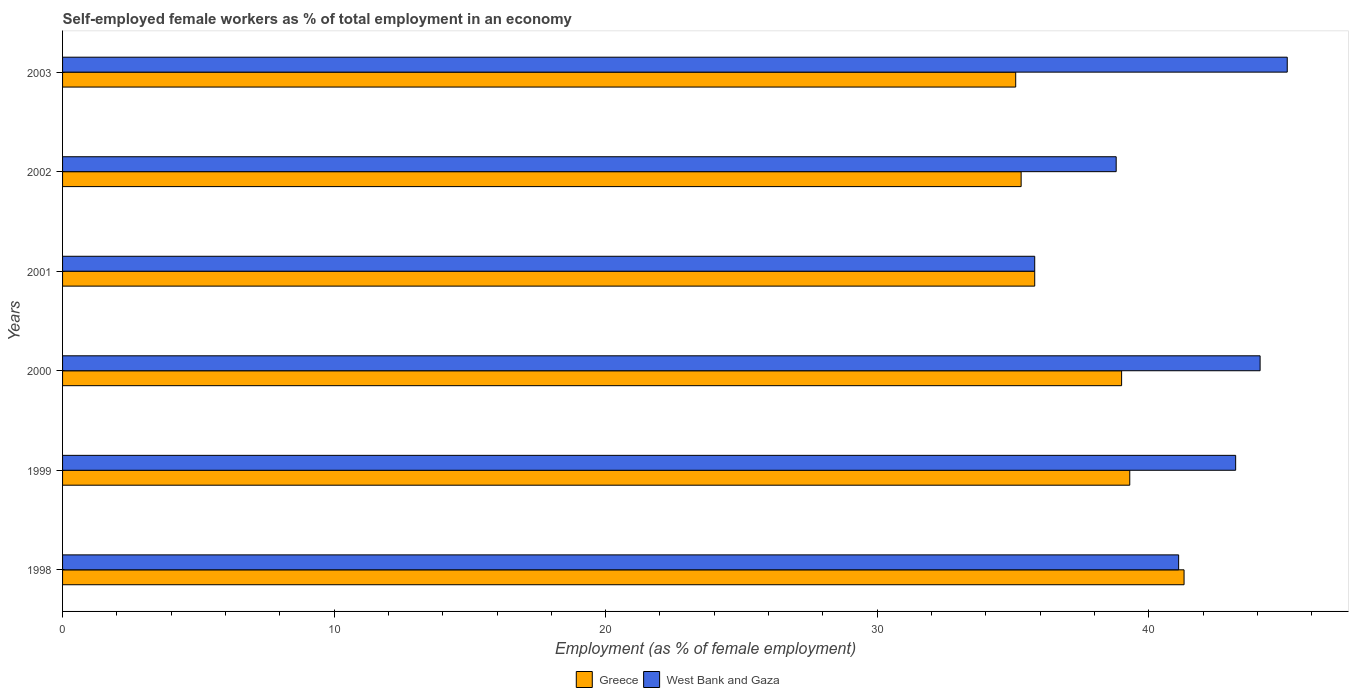How many groups of bars are there?
Offer a terse response. 6. Are the number of bars per tick equal to the number of legend labels?
Your response must be concise. Yes. Are the number of bars on each tick of the Y-axis equal?
Give a very brief answer. Yes. What is the label of the 1st group of bars from the top?
Provide a short and direct response. 2003. What is the percentage of self-employed female workers in Greece in 1999?
Provide a short and direct response. 39.3. Across all years, what is the maximum percentage of self-employed female workers in Greece?
Make the answer very short. 41.3. Across all years, what is the minimum percentage of self-employed female workers in West Bank and Gaza?
Keep it short and to the point. 35.8. In which year was the percentage of self-employed female workers in Greece maximum?
Your answer should be compact. 1998. What is the total percentage of self-employed female workers in Greece in the graph?
Keep it short and to the point. 225.8. What is the difference between the percentage of self-employed female workers in Greece in 1998 and the percentage of self-employed female workers in West Bank and Gaza in 2003?
Provide a succinct answer. -3.8. What is the average percentage of self-employed female workers in West Bank and Gaza per year?
Offer a very short reply. 41.35. What is the ratio of the percentage of self-employed female workers in West Bank and Gaza in 1999 to that in 2000?
Ensure brevity in your answer.  0.98. Is the difference between the percentage of self-employed female workers in West Bank and Gaza in 1999 and 2003 greater than the difference between the percentage of self-employed female workers in Greece in 1999 and 2003?
Your response must be concise. No. What is the difference between the highest and the second highest percentage of self-employed female workers in Greece?
Provide a succinct answer. 2. What is the difference between the highest and the lowest percentage of self-employed female workers in Greece?
Your response must be concise. 6.2. In how many years, is the percentage of self-employed female workers in Greece greater than the average percentage of self-employed female workers in Greece taken over all years?
Your response must be concise. 3. How many bars are there?
Your answer should be very brief. 12. Does the graph contain any zero values?
Provide a succinct answer. No. Does the graph contain grids?
Provide a succinct answer. No. How are the legend labels stacked?
Make the answer very short. Horizontal. What is the title of the graph?
Provide a succinct answer. Self-employed female workers as % of total employment in an economy. What is the label or title of the X-axis?
Offer a terse response. Employment (as % of female employment). What is the label or title of the Y-axis?
Ensure brevity in your answer.  Years. What is the Employment (as % of female employment) in Greece in 1998?
Provide a short and direct response. 41.3. What is the Employment (as % of female employment) in West Bank and Gaza in 1998?
Your answer should be very brief. 41.1. What is the Employment (as % of female employment) of Greece in 1999?
Your response must be concise. 39.3. What is the Employment (as % of female employment) of West Bank and Gaza in 1999?
Your answer should be compact. 43.2. What is the Employment (as % of female employment) in West Bank and Gaza in 2000?
Offer a very short reply. 44.1. What is the Employment (as % of female employment) of Greece in 2001?
Provide a short and direct response. 35.8. What is the Employment (as % of female employment) of West Bank and Gaza in 2001?
Ensure brevity in your answer.  35.8. What is the Employment (as % of female employment) in Greece in 2002?
Your answer should be compact. 35.3. What is the Employment (as % of female employment) of West Bank and Gaza in 2002?
Offer a very short reply. 38.8. What is the Employment (as % of female employment) in Greece in 2003?
Keep it short and to the point. 35.1. What is the Employment (as % of female employment) in West Bank and Gaza in 2003?
Provide a succinct answer. 45.1. Across all years, what is the maximum Employment (as % of female employment) of Greece?
Your answer should be very brief. 41.3. Across all years, what is the maximum Employment (as % of female employment) of West Bank and Gaza?
Your answer should be compact. 45.1. Across all years, what is the minimum Employment (as % of female employment) of Greece?
Keep it short and to the point. 35.1. Across all years, what is the minimum Employment (as % of female employment) of West Bank and Gaza?
Give a very brief answer. 35.8. What is the total Employment (as % of female employment) in Greece in the graph?
Provide a succinct answer. 225.8. What is the total Employment (as % of female employment) in West Bank and Gaza in the graph?
Your answer should be compact. 248.1. What is the difference between the Employment (as % of female employment) in West Bank and Gaza in 1998 and that in 1999?
Offer a terse response. -2.1. What is the difference between the Employment (as % of female employment) of Greece in 1998 and that in 2000?
Provide a succinct answer. 2.3. What is the difference between the Employment (as % of female employment) in West Bank and Gaza in 1998 and that in 2000?
Your response must be concise. -3. What is the difference between the Employment (as % of female employment) in West Bank and Gaza in 1998 and that in 2002?
Make the answer very short. 2.3. What is the difference between the Employment (as % of female employment) of Greece in 1998 and that in 2003?
Make the answer very short. 6.2. What is the difference between the Employment (as % of female employment) of West Bank and Gaza in 1998 and that in 2003?
Your response must be concise. -4. What is the difference between the Employment (as % of female employment) in Greece in 1999 and that in 2001?
Offer a very short reply. 3.5. What is the difference between the Employment (as % of female employment) in West Bank and Gaza in 1999 and that in 2001?
Provide a short and direct response. 7.4. What is the difference between the Employment (as % of female employment) of Greece in 1999 and that in 2002?
Ensure brevity in your answer.  4. What is the difference between the Employment (as % of female employment) in West Bank and Gaza in 1999 and that in 2002?
Give a very brief answer. 4.4. What is the difference between the Employment (as % of female employment) of Greece in 2000 and that in 2002?
Your answer should be very brief. 3.7. What is the difference between the Employment (as % of female employment) in Greece in 2000 and that in 2003?
Offer a terse response. 3.9. What is the difference between the Employment (as % of female employment) in Greece in 2001 and that in 2002?
Provide a succinct answer. 0.5. What is the difference between the Employment (as % of female employment) in West Bank and Gaza in 2001 and that in 2002?
Offer a terse response. -3. What is the difference between the Employment (as % of female employment) of Greece in 2001 and that in 2003?
Give a very brief answer. 0.7. What is the difference between the Employment (as % of female employment) in Greece in 2002 and that in 2003?
Your answer should be compact. 0.2. What is the difference between the Employment (as % of female employment) of Greece in 1998 and the Employment (as % of female employment) of West Bank and Gaza in 1999?
Offer a terse response. -1.9. What is the difference between the Employment (as % of female employment) in Greece in 1998 and the Employment (as % of female employment) in West Bank and Gaza in 2001?
Your answer should be compact. 5.5. What is the difference between the Employment (as % of female employment) in Greece in 1998 and the Employment (as % of female employment) in West Bank and Gaza in 2003?
Your answer should be very brief. -3.8. What is the difference between the Employment (as % of female employment) in Greece in 1999 and the Employment (as % of female employment) in West Bank and Gaza in 2001?
Your answer should be very brief. 3.5. What is the difference between the Employment (as % of female employment) of Greece in 2000 and the Employment (as % of female employment) of West Bank and Gaza in 2001?
Keep it short and to the point. 3.2. What is the difference between the Employment (as % of female employment) in Greece in 2002 and the Employment (as % of female employment) in West Bank and Gaza in 2003?
Offer a very short reply. -9.8. What is the average Employment (as % of female employment) in Greece per year?
Your answer should be very brief. 37.63. What is the average Employment (as % of female employment) in West Bank and Gaza per year?
Your response must be concise. 41.35. In the year 1999, what is the difference between the Employment (as % of female employment) in Greece and Employment (as % of female employment) in West Bank and Gaza?
Your answer should be compact. -3.9. In the year 2000, what is the difference between the Employment (as % of female employment) in Greece and Employment (as % of female employment) in West Bank and Gaza?
Your answer should be very brief. -5.1. In the year 2001, what is the difference between the Employment (as % of female employment) in Greece and Employment (as % of female employment) in West Bank and Gaza?
Offer a very short reply. 0. In the year 2002, what is the difference between the Employment (as % of female employment) in Greece and Employment (as % of female employment) in West Bank and Gaza?
Your response must be concise. -3.5. What is the ratio of the Employment (as % of female employment) in Greece in 1998 to that in 1999?
Your response must be concise. 1.05. What is the ratio of the Employment (as % of female employment) in West Bank and Gaza in 1998 to that in 1999?
Ensure brevity in your answer.  0.95. What is the ratio of the Employment (as % of female employment) of Greece in 1998 to that in 2000?
Your answer should be compact. 1.06. What is the ratio of the Employment (as % of female employment) in West Bank and Gaza in 1998 to that in 2000?
Offer a very short reply. 0.93. What is the ratio of the Employment (as % of female employment) of Greece in 1998 to that in 2001?
Keep it short and to the point. 1.15. What is the ratio of the Employment (as % of female employment) of West Bank and Gaza in 1998 to that in 2001?
Your answer should be compact. 1.15. What is the ratio of the Employment (as % of female employment) of Greece in 1998 to that in 2002?
Your answer should be compact. 1.17. What is the ratio of the Employment (as % of female employment) in West Bank and Gaza in 1998 to that in 2002?
Make the answer very short. 1.06. What is the ratio of the Employment (as % of female employment) of Greece in 1998 to that in 2003?
Make the answer very short. 1.18. What is the ratio of the Employment (as % of female employment) in West Bank and Gaza in 1998 to that in 2003?
Give a very brief answer. 0.91. What is the ratio of the Employment (as % of female employment) of Greece in 1999 to that in 2000?
Your answer should be compact. 1.01. What is the ratio of the Employment (as % of female employment) of West Bank and Gaza in 1999 to that in 2000?
Ensure brevity in your answer.  0.98. What is the ratio of the Employment (as % of female employment) of Greece in 1999 to that in 2001?
Offer a very short reply. 1.1. What is the ratio of the Employment (as % of female employment) in West Bank and Gaza in 1999 to that in 2001?
Give a very brief answer. 1.21. What is the ratio of the Employment (as % of female employment) of Greece in 1999 to that in 2002?
Offer a very short reply. 1.11. What is the ratio of the Employment (as % of female employment) in West Bank and Gaza in 1999 to that in 2002?
Offer a terse response. 1.11. What is the ratio of the Employment (as % of female employment) of Greece in 1999 to that in 2003?
Offer a terse response. 1.12. What is the ratio of the Employment (as % of female employment) in West Bank and Gaza in 1999 to that in 2003?
Make the answer very short. 0.96. What is the ratio of the Employment (as % of female employment) of Greece in 2000 to that in 2001?
Ensure brevity in your answer.  1.09. What is the ratio of the Employment (as % of female employment) of West Bank and Gaza in 2000 to that in 2001?
Provide a succinct answer. 1.23. What is the ratio of the Employment (as % of female employment) in Greece in 2000 to that in 2002?
Your response must be concise. 1.1. What is the ratio of the Employment (as % of female employment) in West Bank and Gaza in 2000 to that in 2002?
Provide a short and direct response. 1.14. What is the ratio of the Employment (as % of female employment) of West Bank and Gaza in 2000 to that in 2003?
Your response must be concise. 0.98. What is the ratio of the Employment (as % of female employment) of Greece in 2001 to that in 2002?
Provide a short and direct response. 1.01. What is the ratio of the Employment (as % of female employment) in West Bank and Gaza in 2001 to that in 2002?
Provide a short and direct response. 0.92. What is the ratio of the Employment (as % of female employment) of Greece in 2001 to that in 2003?
Keep it short and to the point. 1.02. What is the ratio of the Employment (as % of female employment) of West Bank and Gaza in 2001 to that in 2003?
Your answer should be compact. 0.79. What is the ratio of the Employment (as % of female employment) in Greece in 2002 to that in 2003?
Your answer should be compact. 1.01. What is the ratio of the Employment (as % of female employment) in West Bank and Gaza in 2002 to that in 2003?
Offer a terse response. 0.86. What is the difference between the highest and the lowest Employment (as % of female employment) in Greece?
Your answer should be compact. 6.2. 